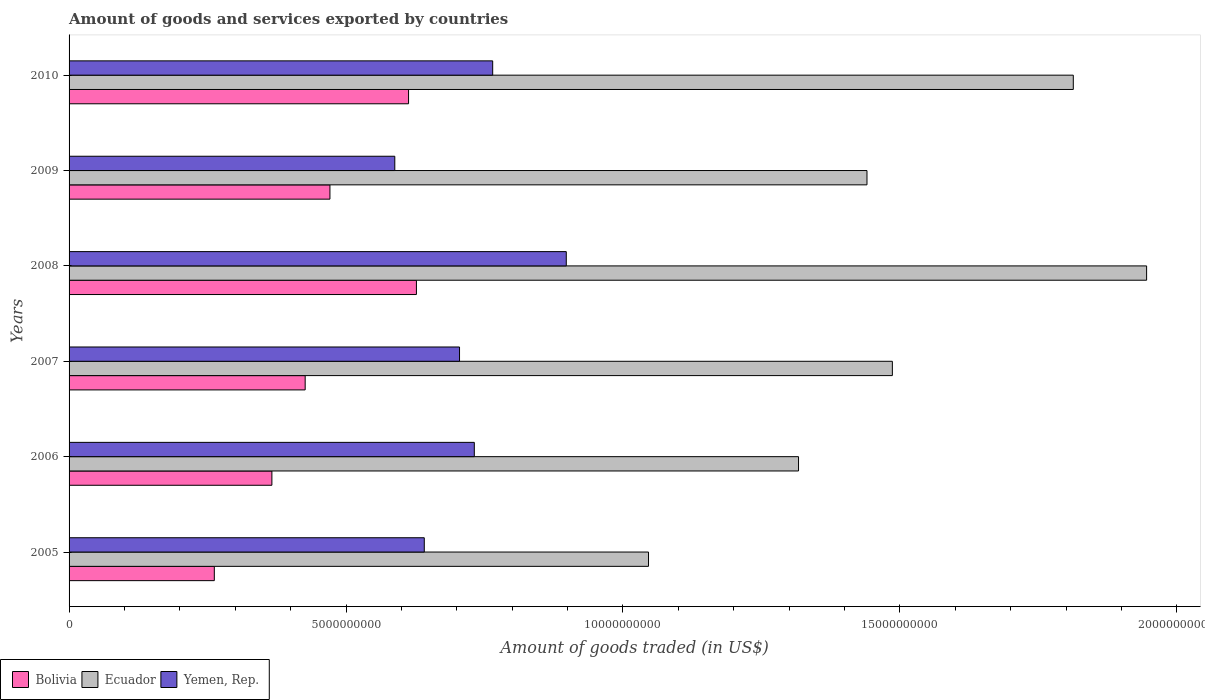How many different coloured bars are there?
Make the answer very short. 3. Are the number of bars per tick equal to the number of legend labels?
Ensure brevity in your answer.  Yes. How many bars are there on the 6th tick from the top?
Ensure brevity in your answer.  3. How many bars are there on the 4th tick from the bottom?
Your answer should be compact. 3. What is the total amount of goods and services exported in Bolivia in 2008?
Your response must be concise. 6.27e+09. Across all years, what is the maximum total amount of goods and services exported in Ecuador?
Make the answer very short. 1.95e+1. Across all years, what is the minimum total amount of goods and services exported in Yemen, Rep.?
Make the answer very short. 5.88e+09. In which year was the total amount of goods and services exported in Bolivia maximum?
Ensure brevity in your answer.  2008. In which year was the total amount of goods and services exported in Ecuador minimum?
Your response must be concise. 2005. What is the total total amount of goods and services exported in Bolivia in the graph?
Keep it short and to the point. 2.77e+1. What is the difference between the total amount of goods and services exported in Ecuador in 2005 and that in 2007?
Ensure brevity in your answer.  -4.40e+09. What is the difference between the total amount of goods and services exported in Bolivia in 2009 and the total amount of goods and services exported in Ecuador in 2007?
Provide a short and direct response. -1.02e+1. What is the average total amount of goods and services exported in Ecuador per year?
Make the answer very short. 1.51e+1. In the year 2009, what is the difference between the total amount of goods and services exported in Yemen, Rep. and total amount of goods and services exported in Ecuador?
Keep it short and to the point. -8.53e+09. What is the ratio of the total amount of goods and services exported in Ecuador in 2007 to that in 2009?
Provide a short and direct response. 1.03. Is the total amount of goods and services exported in Bolivia in 2005 less than that in 2009?
Your answer should be compact. Yes. What is the difference between the highest and the second highest total amount of goods and services exported in Yemen, Rep.?
Offer a terse response. 1.33e+09. What is the difference between the highest and the lowest total amount of goods and services exported in Bolivia?
Ensure brevity in your answer.  3.65e+09. In how many years, is the total amount of goods and services exported in Bolivia greater than the average total amount of goods and services exported in Bolivia taken over all years?
Offer a terse response. 3. What does the 1st bar from the top in 2010 represents?
Provide a succinct answer. Yemen, Rep. What does the 2nd bar from the bottom in 2008 represents?
Give a very brief answer. Ecuador. Is it the case that in every year, the sum of the total amount of goods and services exported in Ecuador and total amount of goods and services exported in Bolivia is greater than the total amount of goods and services exported in Yemen, Rep.?
Give a very brief answer. Yes. How many bars are there?
Provide a succinct answer. 18. Are all the bars in the graph horizontal?
Provide a succinct answer. Yes. How many years are there in the graph?
Offer a very short reply. 6. What is the difference between two consecutive major ticks on the X-axis?
Provide a short and direct response. 5.00e+09. Are the values on the major ticks of X-axis written in scientific E-notation?
Keep it short and to the point. No. Does the graph contain grids?
Provide a short and direct response. No. Where does the legend appear in the graph?
Offer a terse response. Bottom left. How many legend labels are there?
Offer a terse response. 3. What is the title of the graph?
Your answer should be compact. Amount of goods and services exported by countries. Does "Heavily indebted poor countries" appear as one of the legend labels in the graph?
Make the answer very short. No. What is the label or title of the X-axis?
Your answer should be compact. Amount of goods traded (in US$). What is the label or title of the Y-axis?
Provide a short and direct response. Years. What is the Amount of goods traded (in US$) in Bolivia in 2005?
Ensure brevity in your answer.  2.62e+09. What is the Amount of goods traded (in US$) in Ecuador in 2005?
Ensure brevity in your answer.  1.05e+1. What is the Amount of goods traded (in US$) of Yemen, Rep. in 2005?
Ensure brevity in your answer.  6.41e+09. What is the Amount of goods traded (in US$) of Bolivia in 2006?
Provide a short and direct response. 3.66e+09. What is the Amount of goods traded (in US$) of Ecuador in 2006?
Give a very brief answer. 1.32e+1. What is the Amount of goods traded (in US$) of Yemen, Rep. in 2006?
Offer a very short reply. 7.32e+09. What is the Amount of goods traded (in US$) of Bolivia in 2007?
Give a very brief answer. 4.26e+09. What is the Amount of goods traded (in US$) in Ecuador in 2007?
Offer a very short reply. 1.49e+1. What is the Amount of goods traded (in US$) in Yemen, Rep. in 2007?
Ensure brevity in your answer.  7.05e+09. What is the Amount of goods traded (in US$) of Bolivia in 2008?
Offer a very short reply. 6.27e+09. What is the Amount of goods traded (in US$) of Ecuador in 2008?
Make the answer very short. 1.95e+1. What is the Amount of goods traded (in US$) of Yemen, Rep. in 2008?
Ensure brevity in your answer.  8.98e+09. What is the Amount of goods traded (in US$) in Bolivia in 2009?
Offer a terse response. 4.71e+09. What is the Amount of goods traded (in US$) of Ecuador in 2009?
Your response must be concise. 1.44e+1. What is the Amount of goods traded (in US$) in Yemen, Rep. in 2009?
Your response must be concise. 5.88e+09. What is the Amount of goods traded (in US$) of Bolivia in 2010?
Provide a succinct answer. 6.13e+09. What is the Amount of goods traded (in US$) in Ecuador in 2010?
Provide a succinct answer. 1.81e+1. What is the Amount of goods traded (in US$) of Yemen, Rep. in 2010?
Provide a short and direct response. 7.65e+09. Across all years, what is the maximum Amount of goods traded (in US$) of Bolivia?
Your answer should be compact. 6.27e+09. Across all years, what is the maximum Amount of goods traded (in US$) of Ecuador?
Make the answer very short. 1.95e+1. Across all years, what is the maximum Amount of goods traded (in US$) in Yemen, Rep.?
Your answer should be very brief. 8.98e+09. Across all years, what is the minimum Amount of goods traded (in US$) of Bolivia?
Offer a very short reply. 2.62e+09. Across all years, what is the minimum Amount of goods traded (in US$) of Ecuador?
Your response must be concise. 1.05e+1. Across all years, what is the minimum Amount of goods traded (in US$) of Yemen, Rep.?
Provide a succinct answer. 5.88e+09. What is the total Amount of goods traded (in US$) of Bolivia in the graph?
Offer a very short reply. 2.77e+1. What is the total Amount of goods traded (in US$) in Ecuador in the graph?
Provide a short and direct response. 9.05e+1. What is the total Amount of goods traded (in US$) in Yemen, Rep. in the graph?
Give a very brief answer. 4.33e+1. What is the difference between the Amount of goods traded (in US$) in Bolivia in 2005 and that in 2006?
Offer a terse response. -1.04e+09. What is the difference between the Amount of goods traded (in US$) in Ecuador in 2005 and that in 2006?
Your answer should be very brief. -2.71e+09. What is the difference between the Amount of goods traded (in US$) of Yemen, Rep. in 2005 and that in 2006?
Keep it short and to the point. -9.03e+08. What is the difference between the Amount of goods traded (in US$) in Bolivia in 2005 and that in 2007?
Your response must be concise. -1.64e+09. What is the difference between the Amount of goods traded (in US$) of Ecuador in 2005 and that in 2007?
Provide a short and direct response. -4.40e+09. What is the difference between the Amount of goods traded (in US$) in Yemen, Rep. in 2005 and that in 2007?
Offer a terse response. -6.36e+08. What is the difference between the Amount of goods traded (in US$) in Bolivia in 2005 and that in 2008?
Ensure brevity in your answer.  -3.65e+09. What is the difference between the Amount of goods traded (in US$) of Ecuador in 2005 and that in 2008?
Provide a short and direct response. -8.99e+09. What is the difference between the Amount of goods traded (in US$) in Yemen, Rep. in 2005 and that in 2008?
Make the answer very short. -2.56e+09. What is the difference between the Amount of goods traded (in US$) in Bolivia in 2005 and that in 2009?
Offer a terse response. -2.09e+09. What is the difference between the Amount of goods traded (in US$) in Ecuador in 2005 and that in 2009?
Make the answer very short. -3.94e+09. What is the difference between the Amount of goods traded (in US$) in Yemen, Rep. in 2005 and that in 2009?
Make the answer very short. 5.32e+08. What is the difference between the Amount of goods traded (in US$) of Bolivia in 2005 and that in 2010?
Keep it short and to the point. -3.51e+09. What is the difference between the Amount of goods traded (in US$) in Ecuador in 2005 and that in 2010?
Give a very brief answer. -7.67e+09. What is the difference between the Amount of goods traded (in US$) in Yemen, Rep. in 2005 and that in 2010?
Make the answer very short. -1.24e+09. What is the difference between the Amount of goods traded (in US$) of Bolivia in 2006 and that in 2007?
Provide a short and direct response. -6.01e+08. What is the difference between the Amount of goods traded (in US$) in Ecuador in 2006 and that in 2007?
Ensure brevity in your answer.  -1.69e+09. What is the difference between the Amount of goods traded (in US$) of Yemen, Rep. in 2006 and that in 2007?
Your answer should be very brief. 2.67e+08. What is the difference between the Amount of goods traded (in US$) of Bolivia in 2006 and that in 2008?
Your answer should be compact. -2.61e+09. What is the difference between the Amount of goods traded (in US$) in Ecuador in 2006 and that in 2008?
Provide a short and direct response. -6.28e+09. What is the difference between the Amount of goods traded (in US$) in Yemen, Rep. in 2006 and that in 2008?
Your response must be concise. -1.66e+09. What is the difference between the Amount of goods traded (in US$) of Bolivia in 2006 and that in 2009?
Offer a very short reply. -1.05e+09. What is the difference between the Amount of goods traded (in US$) in Ecuador in 2006 and that in 2009?
Make the answer very short. -1.24e+09. What is the difference between the Amount of goods traded (in US$) in Yemen, Rep. in 2006 and that in 2009?
Make the answer very short. 1.44e+09. What is the difference between the Amount of goods traded (in US$) in Bolivia in 2006 and that in 2010?
Offer a very short reply. -2.47e+09. What is the difference between the Amount of goods traded (in US$) in Ecuador in 2006 and that in 2010?
Make the answer very short. -4.96e+09. What is the difference between the Amount of goods traded (in US$) of Yemen, Rep. in 2006 and that in 2010?
Provide a short and direct response. -3.32e+08. What is the difference between the Amount of goods traded (in US$) of Bolivia in 2007 and that in 2008?
Ensure brevity in your answer.  -2.01e+09. What is the difference between the Amount of goods traded (in US$) of Ecuador in 2007 and that in 2008?
Offer a terse response. -4.59e+09. What is the difference between the Amount of goods traded (in US$) in Yemen, Rep. in 2007 and that in 2008?
Offer a terse response. -1.93e+09. What is the difference between the Amount of goods traded (in US$) of Bolivia in 2007 and that in 2009?
Make the answer very short. -4.47e+08. What is the difference between the Amount of goods traded (in US$) of Ecuador in 2007 and that in 2009?
Your response must be concise. 4.58e+08. What is the difference between the Amount of goods traded (in US$) in Yemen, Rep. in 2007 and that in 2009?
Offer a terse response. 1.17e+09. What is the difference between the Amount of goods traded (in US$) of Bolivia in 2007 and that in 2010?
Offer a terse response. -1.87e+09. What is the difference between the Amount of goods traded (in US$) in Ecuador in 2007 and that in 2010?
Keep it short and to the point. -3.27e+09. What is the difference between the Amount of goods traded (in US$) of Yemen, Rep. in 2007 and that in 2010?
Ensure brevity in your answer.  -5.99e+08. What is the difference between the Amount of goods traded (in US$) in Bolivia in 2008 and that in 2009?
Your response must be concise. 1.56e+09. What is the difference between the Amount of goods traded (in US$) of Ecuador in 2008 and that in 2009?
Keep it short and to the point. 5.05e+09. What is the difference between the Amount of goods traded (in US$) of Yemen, Rep. in 2008 and that in 2009?
Make the answer very short. 3.10e+09. What is the difference between the Amount of goods traded (in US$) in Bolivia in 2008 and that in 2010?
Give a very brief answer. 1.42e+08. What is the difference between the Amount of goods traded (in US$) of Ecuador in 2008 and that in 2010?
Your answer should be very brief. 1.32e+09. What is the difference between the Amount of goods traded (in US$) in Yemen, Rep. in 2008 and that in 2010?
Your answer should be very brief. 1.33e+09. What is the difference between the Amount of goods traded (in US$) of Bolivia in 2009 and that in 2010?
Your answer should be very brief. -1.42e+09. What is the difference between the Amount of goods traded (in US$) of Ecuador in 2009 and that in 2010?
Provide a succinct answer. -3.73e+09. What is the difference between the Amount of goods traded (in US$) of Yemen, Rep. in 2009 and that in 2010?
Provide a short and direct response. -1.77e+09. What is the difference between the Amount of goods traded (in US$) of Bolivia in 2005 and the Amount of goods traded (in US$) of Ecuador in 2006?
Provide a succinct answer. -1.05e+1. What is the difference between the Amount of goods traded (in US$) in Bolivia in 2005 and the Amount of goods traded (in US$) in Yemen, Rep. in 2006?
Offer a very short reply. -4.69e+09. What is the difference between the Amount of goods traded (in US$) of Ecuador in 2005 and the Amount of goods traded (in US$) of Yemen, Rep. in 2006?
Ensure brevity in your answer.  3.15e+09. What is the difference between the Amount of goods traded (in US$) of Bolivia in 2005 and the Amount of goods traded (in US$) of Ecuador in 2007?
Your answer should be compact. -1.22e+1. What is the difference between the Amount of goods traded (in US$) of Bolivia in 2005 and the Amount of goods traded (in US$) of Yemen, Rep. in 2007?
Give a very brief answer. -4.43e+09. What is the difference between the Amount of goods traded (in US$) of Ecuador in 2005 and the Amount of goods traded (in US$) of Yemen, Rep. in 2007?
Offer a very short reply. 3.41e+09. What is the difference between the Amount of goods traded (in US$) of Bolivia in 2005 and the Amount of goods traded (in US$) of Ecuador in 2008?
Keep it short and to the point. -1.68e+1. What is the difference between the Amount of goods traded (in US$) of Bolivia in 2005 and the Amount of goods traded (in US$) of Yemen, Rep. in 2008?
Ensure brevity in your answer.  -6.35e+09. What is the difference between the Amount of goods traded (in US$) of Ecuador in 2005 and the Amount of goods traded (in US$) of Yemen, Rep. in 2008?
Offer a very short reply. 1.48e+09. What is the difference between the Amount of goods traded (in US$) in Bolivia in 2005 and the Amount of goods traded (in US$) in Ecuador in 2009?
Give a very brief answer. -1.18e+1. What is the difference between the Amount of goods traded (in US$) of Bolivia in 2005 and the Amount of goods traded (in US$) of Yemen, Rep. in 2009?
Your answer should be very brief. -3.26e+09. What is the difference between the Amount of goods traded (in US$) in Ecuador in 2005 and the Amount of goods traded (in US$) in Yemen, Rep. in 2009?
Keep it short and to the point. 4.58e+09. What is the difference between the Amount of goods traded (in US$) of Bolivia in 2005 and the Amount of goods traded (in US$) of Ecuador in 2010?
Your answer should be compact. -1.55e+1. What is the difference between the Amount of goods traded (in US$) in Bolivia in 2005 and the Amount of goods traded (in US$) in Yemen, Rep. in 2010?
Your answer should be compact. -5.03e+09. What is the difference between the Amount of goods traded (in US$) of Ecuador in 2005 and the Amount of goods traded (in US$) of Yemen, Rep. in 2010?
Give a very brief answer. 2.81e+09. What is the difference between the Amount of goods traded (in US$) of Bolivia in 2006 and the Amount of goods traded (in US$) of Ecuador in 2007?
Provide a succinct answer. -1.12e+1. What is the difference between the Amount of goods traded (in US$) in Bolivia in 2006 and the Amount of goods traded (in US$) in Yemen, Rep. in 2007?
Your response must be concise. -3.39e+09. What is the difference between the Amount of goods traded (in US$) in Ecuador in 2006 and the Amount of goods traded (in US$) in Yemen, Rep. in 2007?
Provide a succinct answer. 6.12e+09. What is the difference between the Amount of goods traded (in US$) in Bolivia in 2006 and the Amount of goods traded (in US$) in Ecuador in 2008?
Ensure brevity in your answer.  -1.58e+1. What is the difference between the Amount of goods traded (in US$) of Bolivia in 2006 and the Amount of goods traded (in US$) of Yemen, Rep. in 2008?
Give a very brief answer. -5.31e+09. What is the difference between the Amount of goods traded (in US$) in Ecuador in 2006 and the Amount of goods traded (in US$) in Yemen, Rep. in 2008?
Provide a succinct answer. 4.19e+09. What is the difference between the Amount of goods traded (in US$) of Bolivia in 2006 and the Amount of goods traded (in US$) of Ecuador in 2009?
Provide a succinct answer. -1.07e+1. What is the difference between the Amount of goods traded (in US$) in Bolivia in 2006 and the Amount of goods traded (in US$) in Yemen, Rep. in 2009?
Give a very brief answer. -2.22e+09. What is the difference between the Amount of goods traded (in US$) in Ecuador in 2006 and the Amount of goods traded (in US$) in Yemen, Rep. in 2009?
Provide a short and direct response. 7.29e+09. What is the difference between the Amount of goods traded (in US$) of Bolivia in 2006 and the Amount of goods traded (in US$) of Ecuador in 2010?
Provide a short and direct response. -1.45e+1. What is the difference between the Amount of goods traded (in US$) in Bolivia in 2006 and the Amount of goods traded (in US$) in Yemen, Rep. in 2010?
Give a very brief answer. -3.99e+09. What is the difference between the Amount of goods traded (in US$) of Ecuador in 2006 and the Amount of goods traded (in US$) of Yemen, Rep. in 2010?
Make the answer very short. 5.52e+09. What is the difference between the Amount of goods traded (in US$) of Bolivia in 2007 and the Amount of goods traded (in US$) of Ecuador in 2008?
Provide a short and direct response. -1.52e+1. What is the difference between the Amount of goods traded (in US$) in Bolivia in 2007 and the Amount of goods traded (in US$) in Yemen, Rep. in 2008?
Offer a very short reply. -4.71e+09. What is the difference between the Amount of goods traded (in US$) of Ecuador in 2007 and the Amount of goods traded (in US$) of Yemen, Rep. in 2008?
Your response must be concise. 5.89e+09. What is the difference between the Amount of goods traded (in US$) of Bolivia in 2007 and the Amount of goods traded (in US$) of Ecuador in 2009?
Keep it short and to the point. -1.01e+1. What is the difference between the Amount of goods traded (in US$) in Bolivia in 2007 and the Amount of goods traded (in US$) in Yemen, Rep. in 2009?
Your answer should be compact. -1.62e+09. What is the difference between the Amount of goods traded (in US$) of Ecuador in 2007 and the Amount of goods traded (in US$) of Yemen, Rep. in 2009?
Offer a terse response. 8.98e+09. What is the difference between the Amount of goods traded (in US$) in Bolivia in 2007 and the Amount of goods traded (in US$) in Ecuador in 2010?
Ensure brevity in your answer.  -1.39e+1. What is the difference between the Amount of goods traded (in US$) in Bolivia in 2007 and the Amount of goods traded (in US$) in Yemen, Rep. in 2010?
Make the answer very short. -3.39e+09. What is the difference between the Amount of goods traded (in US$) in Ecuador in 2007 and the Amount of goods traded (in US$) in Yemen, Rep. in 2010?
Your answer should be very brief. 7.22e+09. What is the difference between the Amount of goods traded (in US$) of Bolivia in 2008 and the Amount of goods traded (in US$) of Ecuador in 2009?
Make the answer very short. -8.13e+09. What is the difference between the Amount of goods traded (in US$) of Bolivia in 2008 and the Amount of goods traded (in US$) of Yemen, Rep. in 2009?
Provide a short and direct response. 3.90e+08. What is the difference between the Amount of goods traded (in US$) of Ecuador in 2008 and the Amount of goods traded (in US$) of Yemen, Rep. in 2009?
Provide a short and direct response. 1.36e+1. What is the difference between the Amount of goods traded (in US$) in Bolivia in 2008 and the Amount of goods traded (in US$) in Ecuador in 2010?
Provide a short and direct response. -1.19e+1. What is the difference between the Amount of goods traded (in US$) of Bolivia in 2008 and the Amount of goods traded (in US$) of Yemen, Rep. in 2010?
Make the answer very short. -1.38e+09. What is the difference between the Amount of goods traded (in US$) in Ecuador in 2008 and the Amount of goods traded (in US$) in Yemen, Rep. in 2010?
Provide a succinct answer. 1.18e+1. What is the difference between the Amount of goods traded (in US$) in Bolivia in 2009 and the Amount of goods traded (in US$) in Ecuador in 2010?
Ensure brevity in your answer.  -1.34e+1. What is the difference between the Amount of goods traded (in US$) of Bolivia in 2009 and the Amount of goods traded (in US$) of Yemen, Rep. in 2010?
Make the answer very short. -2.94e+09. What is the difference between the Amount of goods traded (in US$) in Ecuador in 2009 and the Amount of goods traded (in US$) in Yemen, Rep. in 2010?
Provide a succinct answer. 6.76e+09. What is the average Amount of goods traded (in US$) in Bolivia per year?
Offer a very short reply. 4.61e+09. What is the average Amount of goods traded (in US$) of Ecuador per year?
Give a very brief answer. 1.51e+1. What is the average Amount of goods traded (in US$) of Yemen, Rep. per year?
Your response must be concise. 7.21e+09. In the year 2005, what is the difference between the Amount of goods traded (in US$) in Bolivia and Amount of goods traded (in US$) in Ecuador?
Ensure brevity in your answer.  -7.84e+09. In the year 2005, what is the difference between the Amount of goods traded (in US$) in Bolivia and Amount of goods traded (in US$) in Yemen, Rep.?
Give a very brief answer. -3.79e+09. In the year 2005, what is the difference between the Amount of goods traded (in US$) in Ecuador and Amount of goods traded (in US$) in Yemen, Rep.?
Give a very brief answer. 4.05e+09. In the year 2006, what is the difference between the Amount of goods traded (in US$) in Bolivia and Amount of goods traded (in US$) in Ecuador?
Keep it short and to the point. -9.51e+09. In the year 2006, what is the difference between the Amount of goods traded (in US$) of Bolivia and Amount of goods traded (in US$) of Yemen, Rep.?
Provide a short and direct response. -3.65e+09. In the year 2006, what is the difference between the Amount of goods traded (in US$) in Ecuador and Amount of goods traded (in US$) in Yemen, Rep.?
Ensure brevity in your answer.  5.85e+09. In the year 2007, what is the difference between the Amount of goods traded (in US$) in Bolivia and Amount of goods traded (in US$) in Ecuador?
Keep it short and to the point. -1.06e+1. In the year 2007, what is the difference between the Amount of goods traded (in US$) of Bolivia and Amount of goods traded (in US$) of Yemen, Rep.?
Your answer should be very brief. -2.79e+09. In the year 2007, what is the difference between the Amount of goods traded (in US$) of Ecuador and Amount of goods traded (in US$) of Yemen, Rep.?
Offer a terse response. 7.81e+09. In the year 2008, what is the difference between the Amount of goods traded (in US$) of Bolivia and Amount of goods traded (in US$) of Ecuador?
Your answer should be compact. -1.32e+1. In the year 2008, what is the difference between the Amount of goods traded (in US$) of Bolivia and Amount of goods traded (in US$) of Yemen, Rep.?
Your answer should be very brief. -2.71e+09. In the year 2008, what is the difference between the Amount of goods traded (in US$) in Ecuador and Amount of goods traded (in US$) in Yemen, Rep.?
Ensure brevity in your answer.  1.05e+1. In the year 2009, what is the difference between the Amount of goods traded (in US$) in Bolivia and Amount of goods traded (in US$) in Ecuador?
Provide a succinct answer. -9.70e+09. In the year 2009, what is the difference between the Amount of goods traded (in US$) in Bolivia and Amount of goods traded (in US$) in Yemen, Rep.?
Make the answer very short. -1.17e+09. In the year 2009, what is the difference between the Amount of goods traded (in US$) of Ecuador and Amount of goods traded (in US$) of Yemen, Rep.?
Your answer should be compact. 8.53e+09. In the year 2010, what is the difference between the Amount of goods traded (in US$) of Bolivia and Amount of goods traded (in US$) of Ecuador?
Give a very brief answer. -1.20e+1. In the year 2010, what is the difference between the Amount of goods traded (in US$) of Bolivia and Amount of goods traded (in US$) of Yemen, Rep.?
Offer a very short reply. -1.52e+09. In the year 2010, what is the difference between the Amount of goods traded (in US$) in Ecuador and Amount of goods traded (in US$) in Yemen, Rep.?
Your response must be concise. 1.05e+1. What is the ratio of the Amount of goods traded (in US$) of Bolivia in 2005 to that in 2006?
Provide a short and direct response. 0.72. What is the ratio of the Amount of goods traded (in US$) of Ecuador in 2005 to that in 2006?
Keep it short and to the point. 0.79. What is the ratio of the Amount of goods traded (in US$) in Yemen, Rep. in 2005 to that in 2006?
Keep it short and to the point. 0.88. What is the ratio of the Amount of goods traded (in US$) in Bolivia in 2005 to that in 2007?
Your answer should be compact. 0.62. What is the ratio of the Amount of goods traded (in US$) of Ecuador in 2005 to that in 2007?
Keep it short and to the point. 0.7. What is the ratio of the Amount of goods traded (in US$) in Yemen, Rep. in 2005 to that in 2007?
Give a very brief answer. 0.91. What is the ratio of the Amount of goods traded (in US$) in Bolivia in 2005 to that in 2008?
Your answer should be compact. 0.42. What is the ratio of the Amount of goods traded (in US$) of Ecuador in 2005 to that in 2008?
Offer a very short reply. 0.54. What is the ratio of the Amount of goods traded (in US$) in Yemen, Rep. in 2005 to that in 2008?
Keep it short and to the point. 0.71. What is the ratio of the Amount of goods traded (in US$) of Bolivia in 2005 to that in 2009?
Keep it short and to the point. 0.56. What is the ratio of the Amount of goods traded (in US$) of Ecuador in 2005 to that in 2009?
Keep it short and to the point. 0.73. What is the ratio of the Amount of goods traded (in US$) of Yemen, Rep. in 2005 to that in 2009?
Your response must be concise. 1.09. What is the ratio of the Amount of goods traded (in US$) in Bolivia in 2005 to that in 2010?
Provide a short and direct response. 0.43. What is the ratio of the Amount of goods traded (in US$) in Ecuador in 2005 to that in 2010?
Your answer should be compact. 0.58. What is the ratio of the Amount of goods traded (in US$) in Yemen, Rep. in 2005 to that in 2010?
Offer a terse response. 0.84. What is the ratio of the Amount of goods traded (in US$) of Bolivia in 2006 to that in 2007?
Offer a terse response. 0.86. What is the ratio of the Amount of goods traded (in US$) of Ecuador in 2006 to that in 2007?
Make the answer very short. 0.89. What is the ratio of the Amount of goods traded (in US$) of Yemen, Rep. in 2006 to that in 2007?
Offer a very short reply. 1.04. What is the ratio of the Amount of goods traded (in US$) of Bolivia in 2006 to that in 2008?
Provide a succinct answer. 0.58. What is the ratio of the Amount of goods traded (in US$) in Ecuador in 2006 to that in 2008?
Your answer should be very brief. 0.68. What is the ratio of the Amount of goods traded (in US$) in Yemen, Rep. in 2006 to that in 2008?
Provide a succinct answer. 0.81. What is the ratio of the Amount of goods traded (in US$) of Bolivia in 2006 to that in 2009?
Your answer should be compact. 0.78. What is the ratio of the Amount of goods traded (in US$) in Ecuador in 2006 to that in 2009?
Provide a succinct answer. 0.91. What is the ratio of the Amount of goods traded (in US$) of Yemen, Rep. in 2006 to that in 2009?
Your answer should be very brief. 1.24. What is the ratio of the Amount of goods traded (in US$) in Bolivia in 2006 to that in 2010?
Give a very brief answer. 0.6. What is the ratio of the Amount of goods traded (in US$) in Ecuador in 2006 to that in 2010?
Ensure brevity in your answer.  0.73. What is the ratio of the Amount of goods traded (in US$) in Yemen, Rep. in 2006 to that in 2010?
Provide a short and direct response. 0.96. What is the ratio of the Amount of goods traded (in US$) in Bolivia in 2007 to that in 2008?
Offer a terse response. 0.68. What is the ratio of the Amount of goods traded (in US$) of Ecuador in 2007 to that in 2008?
Provide a succinct answer. 0.76. What is the ratio of the Amount of goods traded (in US$) in Yemen, Rep. in 2007 to that in 2008?
Your answer should be compact. 0.79. What is the ratio of the Amount of goods traded (in US$) of Bolivia in 2007 to that in 2009?
Your answer should be compact. 0.91. What is the ratio of the Amount of goods traded (in US$) in Ecuador in 2007 to that in 2009?
Your answer should be very brief. 1.03. What is the ratio of the Amount of goods traded (in US$) of Yemen, Rep. in 2007 to that in 2009?
Your response must be concise. 1.2. What is the ratio of the Amount of goods traded (in US$) of Bolivia in 2007 to that in 2010?
Offer a very short reply. 0.7. What is the ratio of the Amount of goods traded (in US$) in Ecuador in 2007 to that in 2010?
Give a very brief answer. 0.82. What is the ratio of the Amount of goods traded (in US$) in Yemen, Rep. in 2007 to that in 2010?
Your response must be concise. 0.92. What is the ratio of the Amount of goods traded (in US$) in Bolivia in 2008 to that in 2009?
Keep it short and to the point. 1.33. What is the ratio of the Amount of goods traded (in US$) of Ecuador in 2008 to that in 2009?
Your answer should be compact. 1.35. What is the ratio of the Amount of goods traded (in US$) of Yemen, Rep. in 2008 to that in 2009?
Offer a very short reply. 1.53. What is the ratio of the Amount of goods traded (in US$) in Bolivia in 2008 to that in 2010?
Offer a very short reply. 1.02. What is the ratio of the Amount of goods traded (in US$) in Ecuador in 2008 to that in 2010?
Keep it short and to the point. 1.07. What is the ratio of the Amount of goods traded (in US$) in Yemen, Rep. in 2008 to that in 2010?
Provide a succinct answer. 1.17. What is the ratio of the Amount of goods traded (in US$) in Bolivia in 2009 to that in 2010?
Offer a very short reply. 0.77. What is the ratio of the Amount of goods traded (in US$) of Ecuador in 2009 to that in 2010?
Provide a short and direct response. 0.79. What is the ratio of the Amount of goods traded (in US$) of Yemen, Rep. in 2009 to that in 2010?
Your answer should be very brief. 0.77. What is the difference between the highest and the second highest Amount of goods traded (in US$) in Bolivia?
Ensure brevity in your answer.  1.42e+08. What is the difference between the highest and the second highest Amount of goods traded (in US$) in Ecuador?
Provide a short and direct response. 1.32e+09. What is the difference between the highest and the second highest Amount of goods traded (in US$) in Yemen, Rep.?
Give a very brief answer. 1.33e+09. What is the difference between the highest and the lowest Amount of goods traded (in US$) of Bolivia?
Ensure brevity in your answer.  3.65e+09. What is the difference between the highest and the lowest Amount of goods traded (in US$) in Ecuador?
Your answer should be compact. 8.99e+09. What is the difference between the highest and the lowest Amount of goods traded (in US$) of Yemen, Rep.?
Offer a terse response. 3.10e+09. 